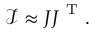<formula> <loc_0><loc_0><loc_500><loc_500>\mathcal { I } \approx J J ^ { T } .</formula> 